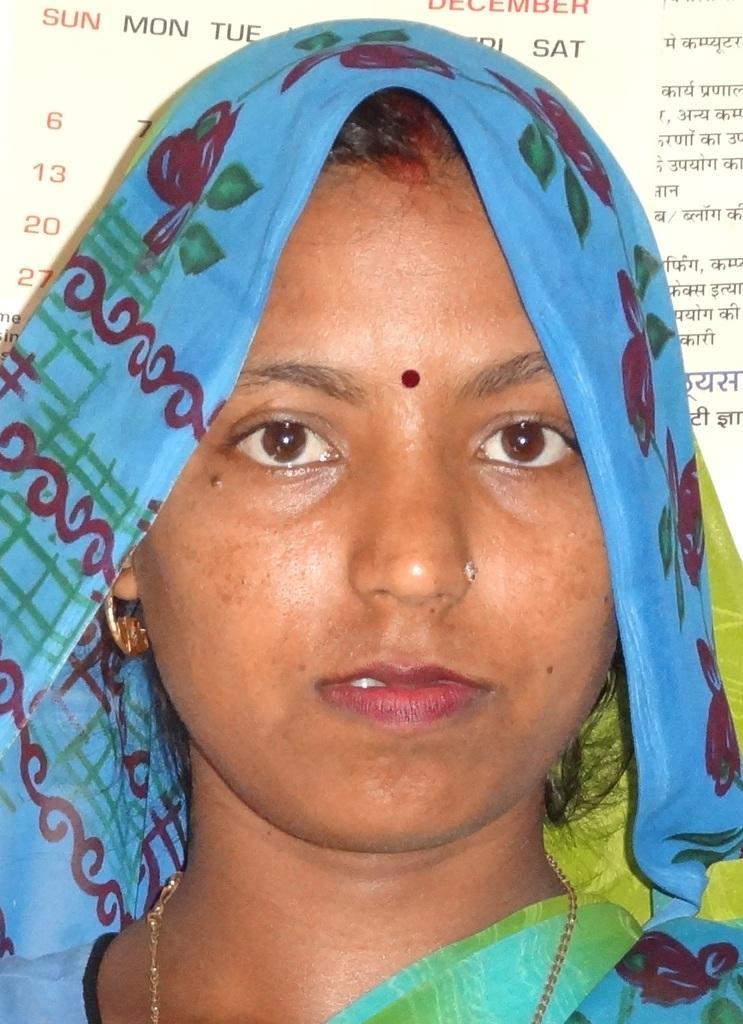Can you describe this image briefly? In this image we can see a woman. On the backside we can see a paper with some text and numbers on it. 